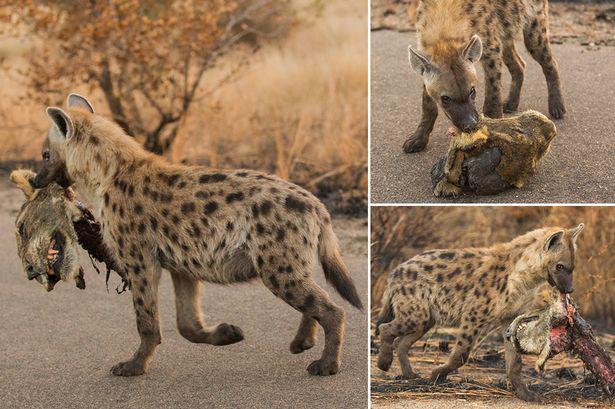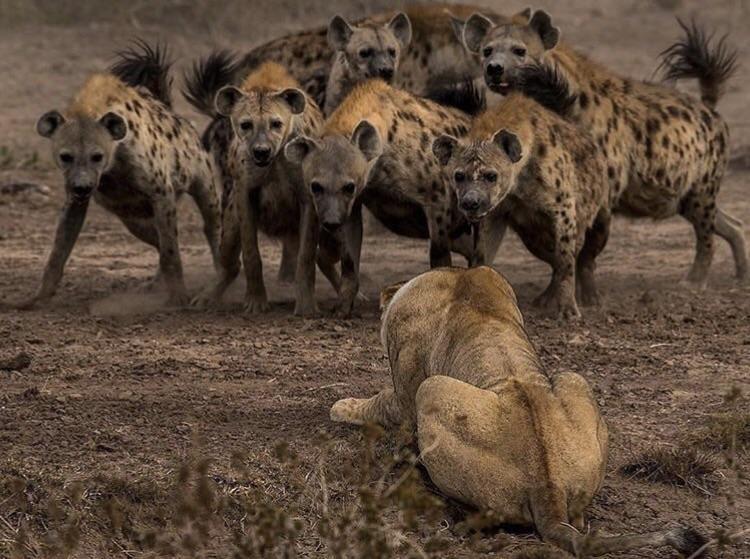The first image is the image on the left, the second image is the image on the right. For the images displayed, is the sentence "A hyena is carrying off the head of its prey in one of the images." factually correct? Answer yes or no. Yes. The first image is the image on the left, the second image is the image on the right. For the images shown, is this caption "At least one animal is carrying a piece of its prey in its mouth." true? Answer yes or no. Yes. 